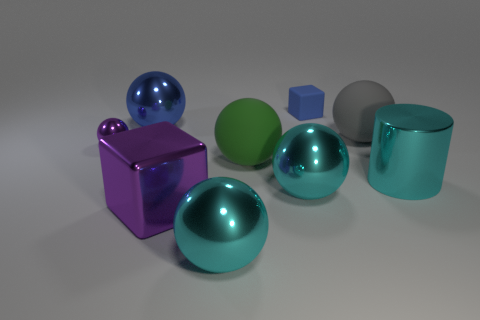Is the number of large yellow shiny balls less than the number of cyan shiny balls?
Offer a terse response. Yes. What material is the blue thing that is on the left side of the small blue thing that is behind the big cyan shiny object to the right of the blue block?
Offer a terse response. Metal. What is the material of the big gray thing?
Provide a succinct answer. Rubber. There is a small object that is on the left side of the metal cube; does it have the same color as the matte thing behind the blue metal thing?
Offer a terse response. No. Is the number of big purple matte balls greater than the number of small purple things?
Offer a very short reply. No. What number of large matte balls have the same color as the rubber block?
Make the answer very short. 0. The other thing that is the same shape as the small blue thing is what color?
Offer a very short reply. Purple. There is a large ball that is both behind the green object and in front of the big blue shiny object; what is it made of?
Offer a very short reply. Rubber. Is the material of the block behind the large cyan shiny cylinder the same as the small object in front of the gray rubber thing?
Give a very brief answer. No. The rubber block has what size?
Give a very brief answer. Small. 